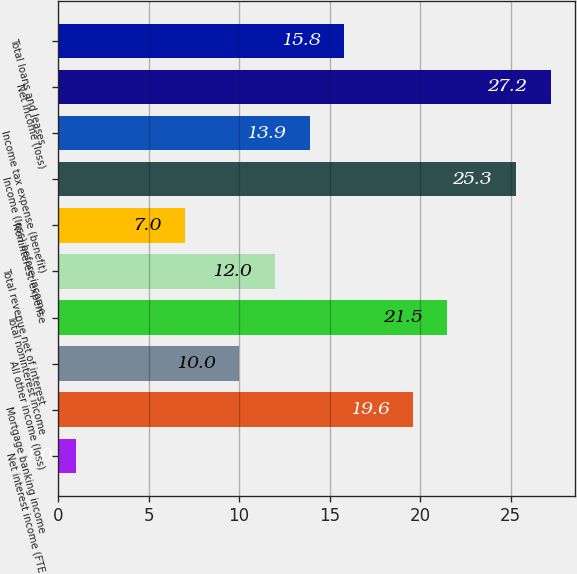<chart> <loc_0><loc_0><loc_500><loc_500><bar_chart><fcel>Net interest income (FTE<fcel>Mortgage banking income<fcel>All other income (loss)<fcel>Total noninterest income<fcel>Total revenue net of interest<fcel>Noninterest expense<fcel>Income (loss) before income<fcel>Income tax expense (benefit)<fcel>Net income (loss)<fcel>Total loans and leases<nl><fcel>1<fcel>19.6<fcel>10<fcel>21.5<fcel>12<fcel>7<fcel>25.3<fcel>13.9<fcel>27.2<fcel>15.8<nl></chart> 